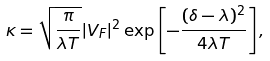<formula> <loc_0><loc_0><loc_500><loc_500>\kappa = \sqrt { \frac { \pi } { \lambda T } } | V _ { F } | ^ { 2 } \exp \left [ - \frac { ( \delta - \lambda ) ^ { 2 } } { 4 \lambda T } \right ] ,</formula> 